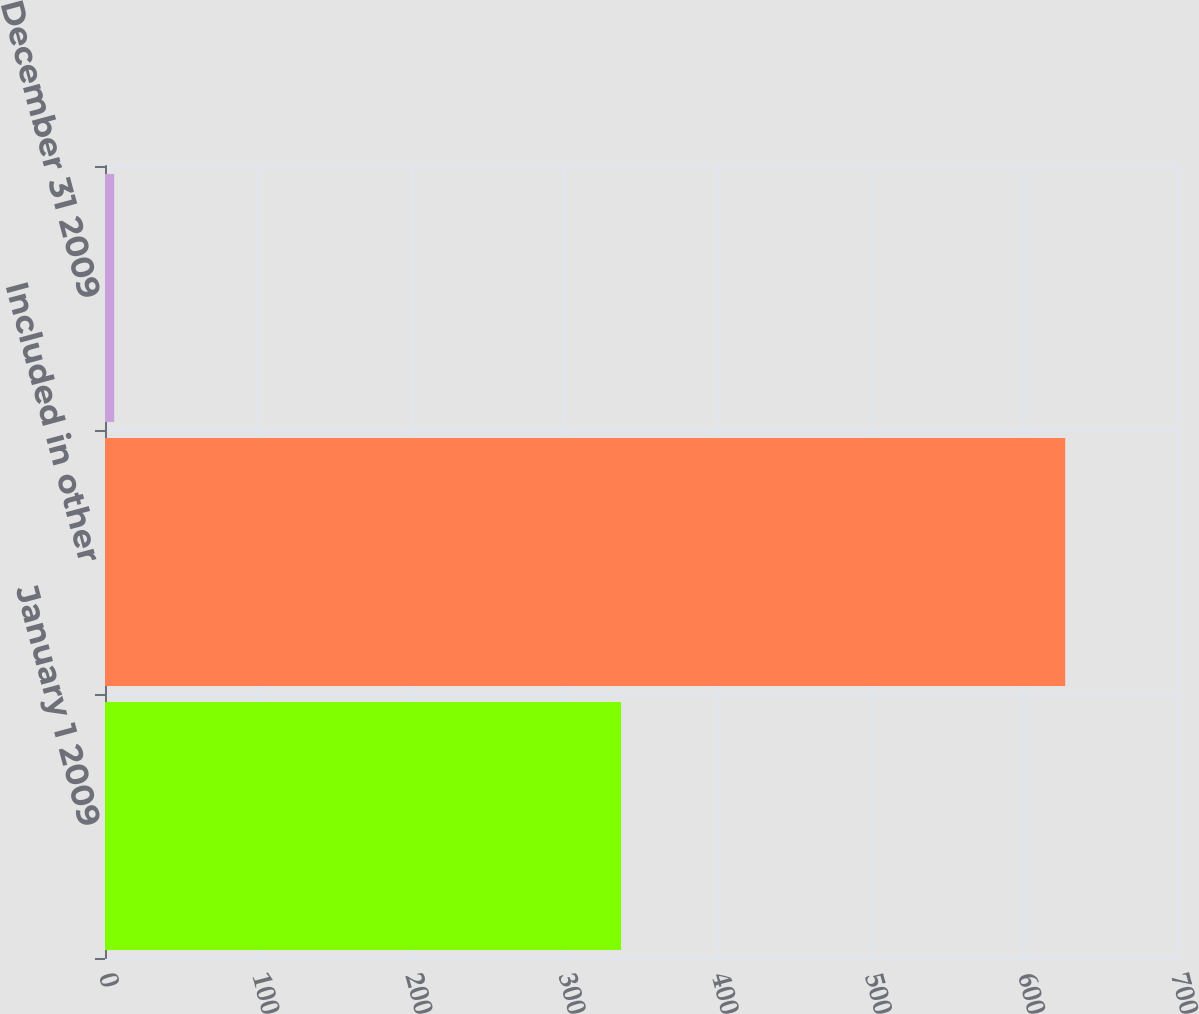<chart> <loc_0><loc_0><loc_500><loc_500><bar_chart><fcel>January 1 2009<fcel>Included in other<fcel>December 31 2009<nl><fcel>337<fcel>627<fcel>6<nl></chart> 